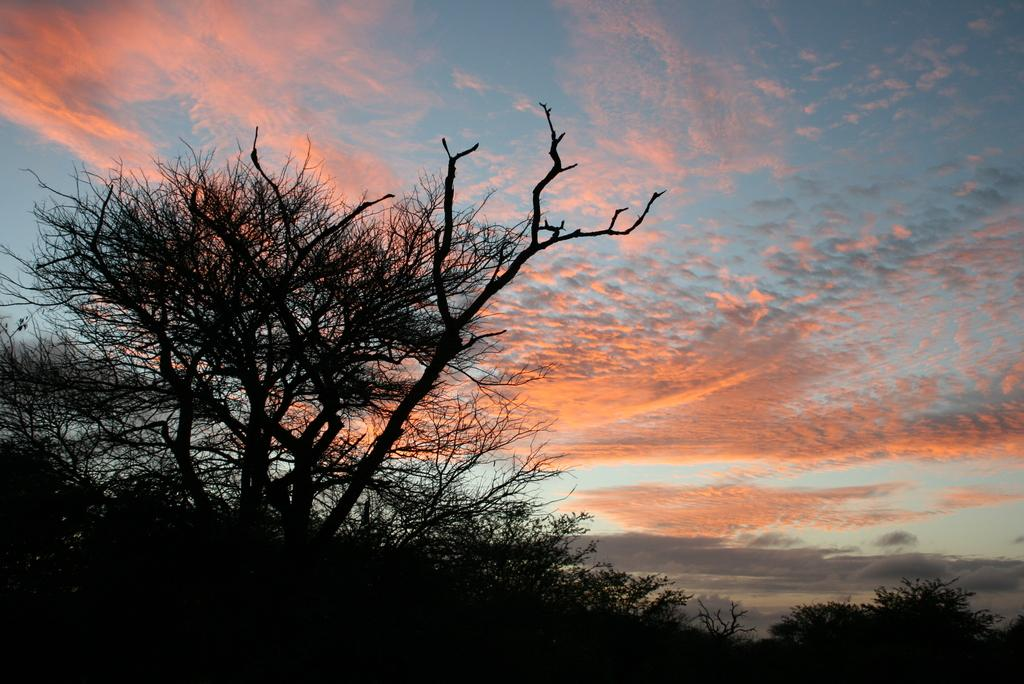What is the primary feature of the image? There are many trees in the image. What can be seen in the background of the image? The sky is visible in the background of the image. How would you describe the sky in the image? The sky appears to be cloudy. How many socks are hanging from the trees in the image? There are no socks present in the image; it features trees and a cloudy sky. What type of brain can be seen in the image? There is no brain present in the image; it features trees and a cloudy sky. 